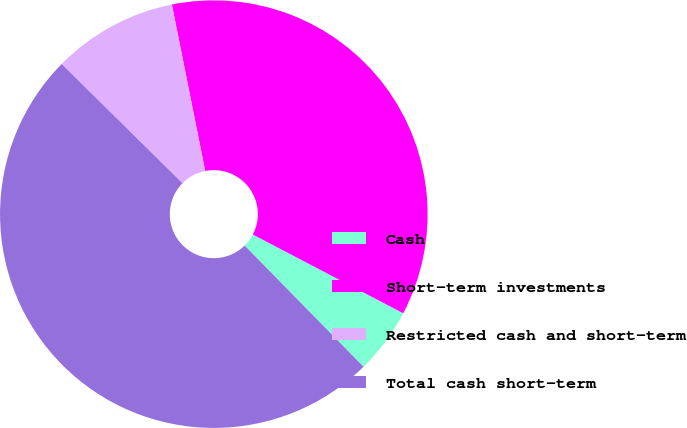<chart> <loc_0><loc_0><loc_500><loc_500><pie_chart><fcel>Cash<fcel>Short-term investments<fcel>Restricted cash and short-term<fcel>Total cash short-term<nl><fcel>4.98%<fcel>35.82%<fcel>9.46%<fcel>49.74%<nl></chart> 